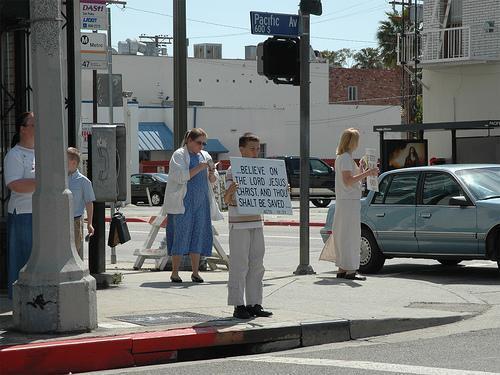How many people are holding signs?
Give a very brief answer. 2. 